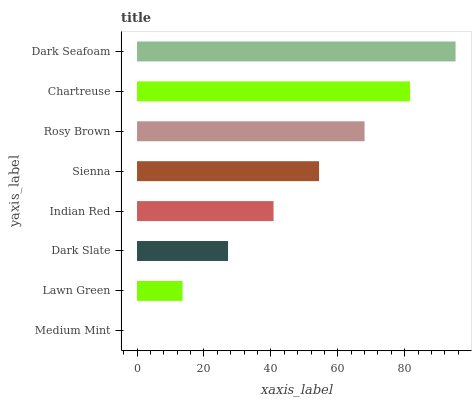Is Medium Mint the minimum?
Answer yes or no. Yes. Is Dark Seafoam the maximum?
Answer yes or no. Yes. Is Lawn Green the minimum?
Answer yes or no. No. Is Lawn Green the maximum?
Answer yes or no. No. Is Lawn Green greater than Medium Mint?
Answer yes or no. Yes. Is Medium Mint less than Lawn Green?
Answer yes or no. Yes. Is Medium Mint greater than Lawn Green?
Answer yes or no. No. Is Lawn Green less than Medium Mint?
Answer yes or no. No. Is Sienna the high median?
Answer yes or no. Yes. Is Indian Red the low median?
Answer yes or no. Yes. Is Dark Seafoam the high median?
Answer yes or no. No. Is Rosy Brown the low median?
Answer yes or no. No. 